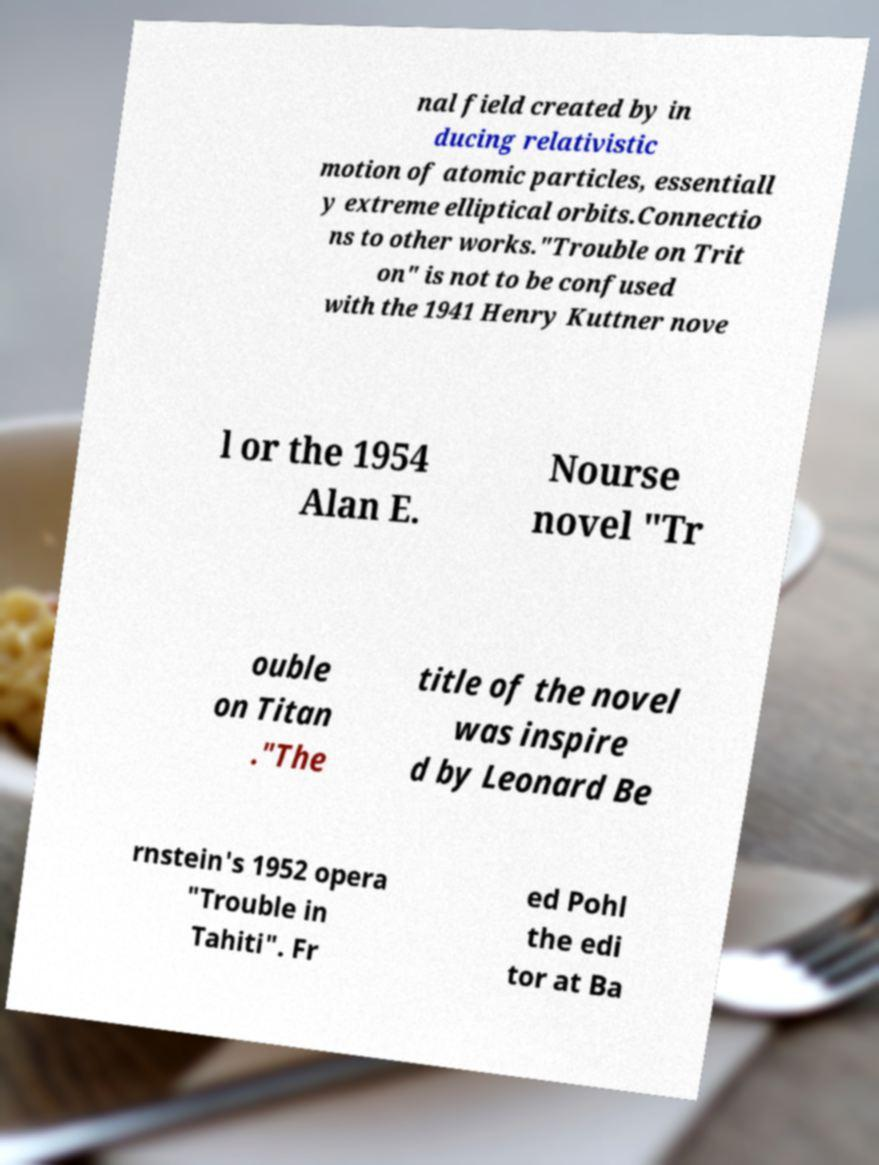What messages or text are displayed in this image? I need them in a readable, typed format. nal field created by in ducing relativistic motion of atomic particles, essentiall y extreme elliptical orbits.Connectio ns to other works."Trouble on Trit on" is not to be confused with the 1941 Henry Kuttner nove l or the 1954 Alan E. Nourse novel "Tr ouble on Titan ."The title of the novel was inspire d by Leonard Be rnstein's 1952 opera "Trouble in Tahiti". Fr ed Pohl the edi tor at Ba 